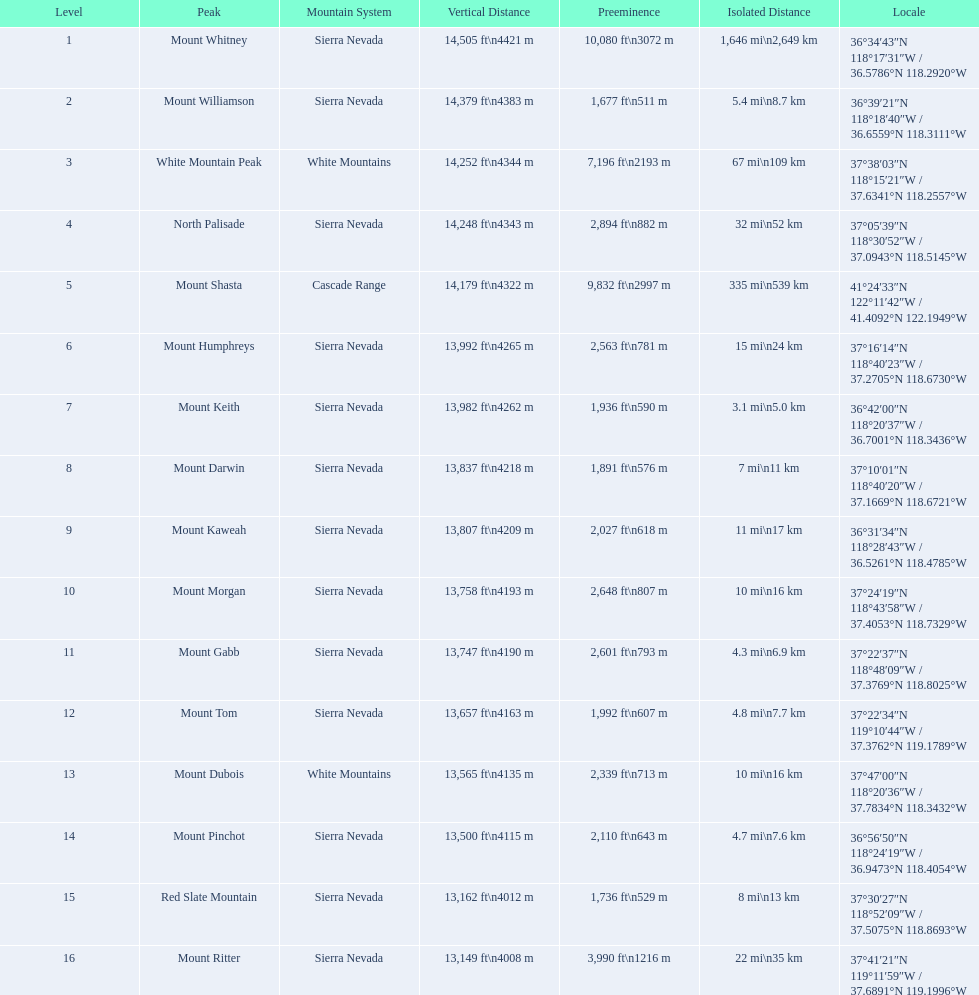Which mountain peaks have a prominence over 9,000 ft? Mount Whitney, Mount Shasta. Of those, which one has the the highest prominence? Mount Whitney. Which mountain peaks are lower than 14,000 ft? Mount Humphreys, Mount Keith, Mount Darwin, Mount Kaweah, Mount Morgan, Mount Gabb, Mount Tom, Mount Dubois, Mount Pinchot, Red Slate Mountain, Mount Ritter. Are any of them below 13,500? if so, which ones? Red Slate Mountain, Mount Ritter. What's the lowest peak? 13,149 ft\n4008 m. Which one is that? Mount Ritter. 